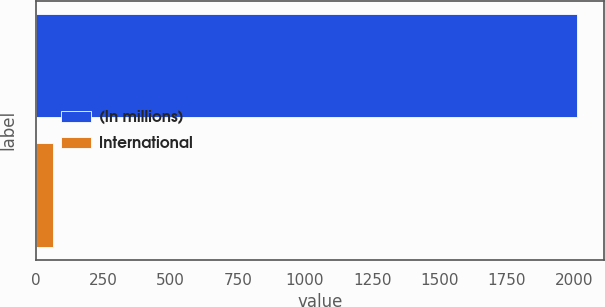Convert chart to OTSL. <chart><loc_0><loc_0><loc_500><loc_500><bar_chart><fcel>(In millions)<fcel>International<nl><fcel>2011<fcel>63<nl></chart> 